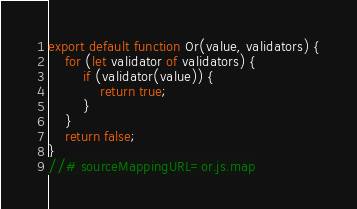Convert code to text. <code><loc_0><loc_0><loc_500><loc_500><_JavaScript_>export default function Or(value, validators) {
    for (let validator of validators) {
        if (validator(value)) {
            return true;
        }
    }
    return false;
}
//# sourceMappingURL=or.js.map</code> 